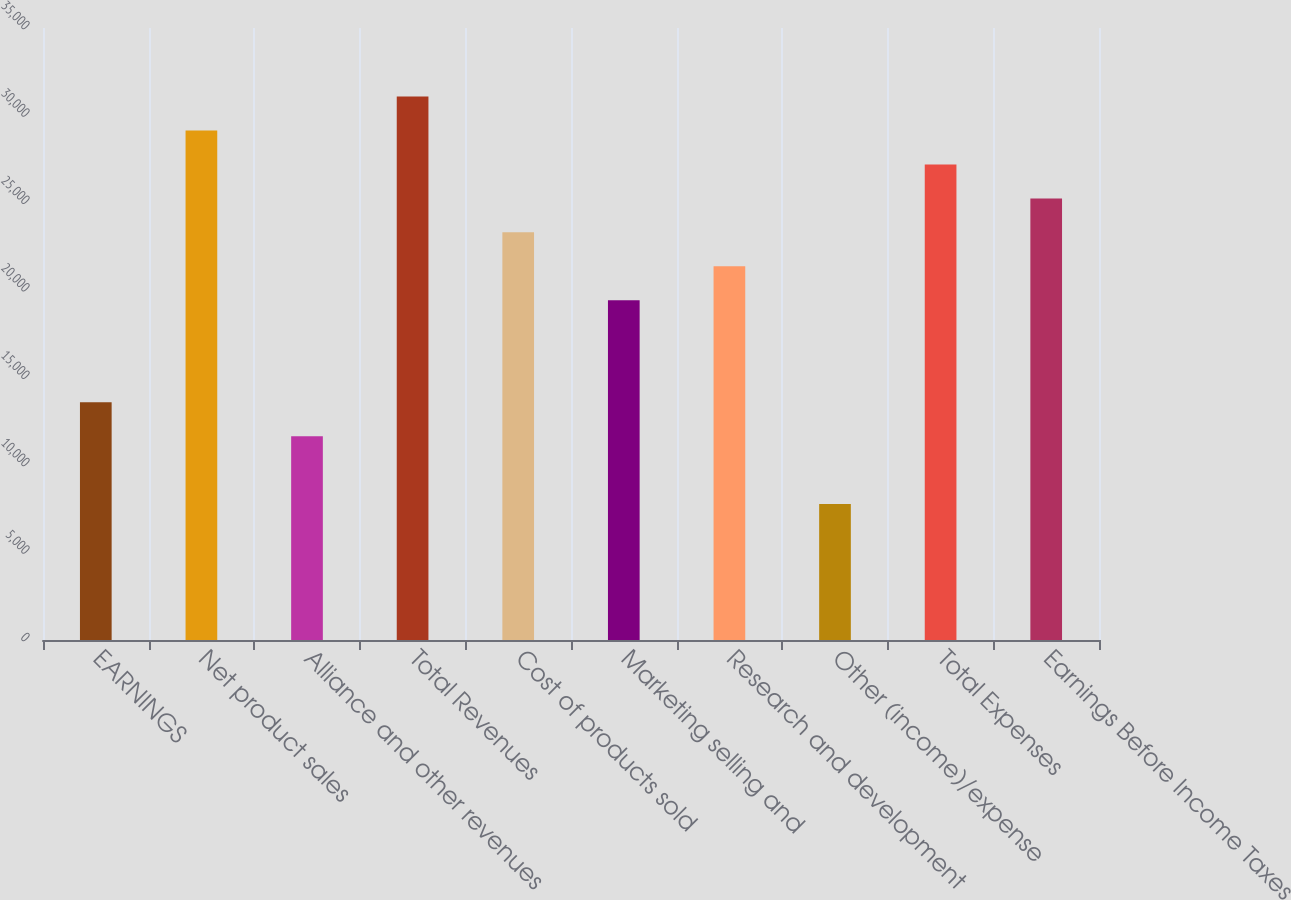Convert chart to OTSL. <chart><loc_0><loc_0><loc_500><loc_500><bar_chart><fcel>EARNINGS<fcel>Net product sales<fcel>Alliance and other revenues<fcel>Total Revenues<fcel>Cost of products sold<fcel>Marketing selling and<fcel>Research and development<fcel>Other (income)/expense<fcel>Total Expenses<fcel>Earnings Before Income Taxes<nl><fcel>13599.4<fcel>29139.8<fcel>11656.8<fcel>31082.3<fcel>23312.1<fcel>19427<fcel>21369.6<fcel>7771.73<fcel>27197.2<fcel>25254.7<nl></chart> 